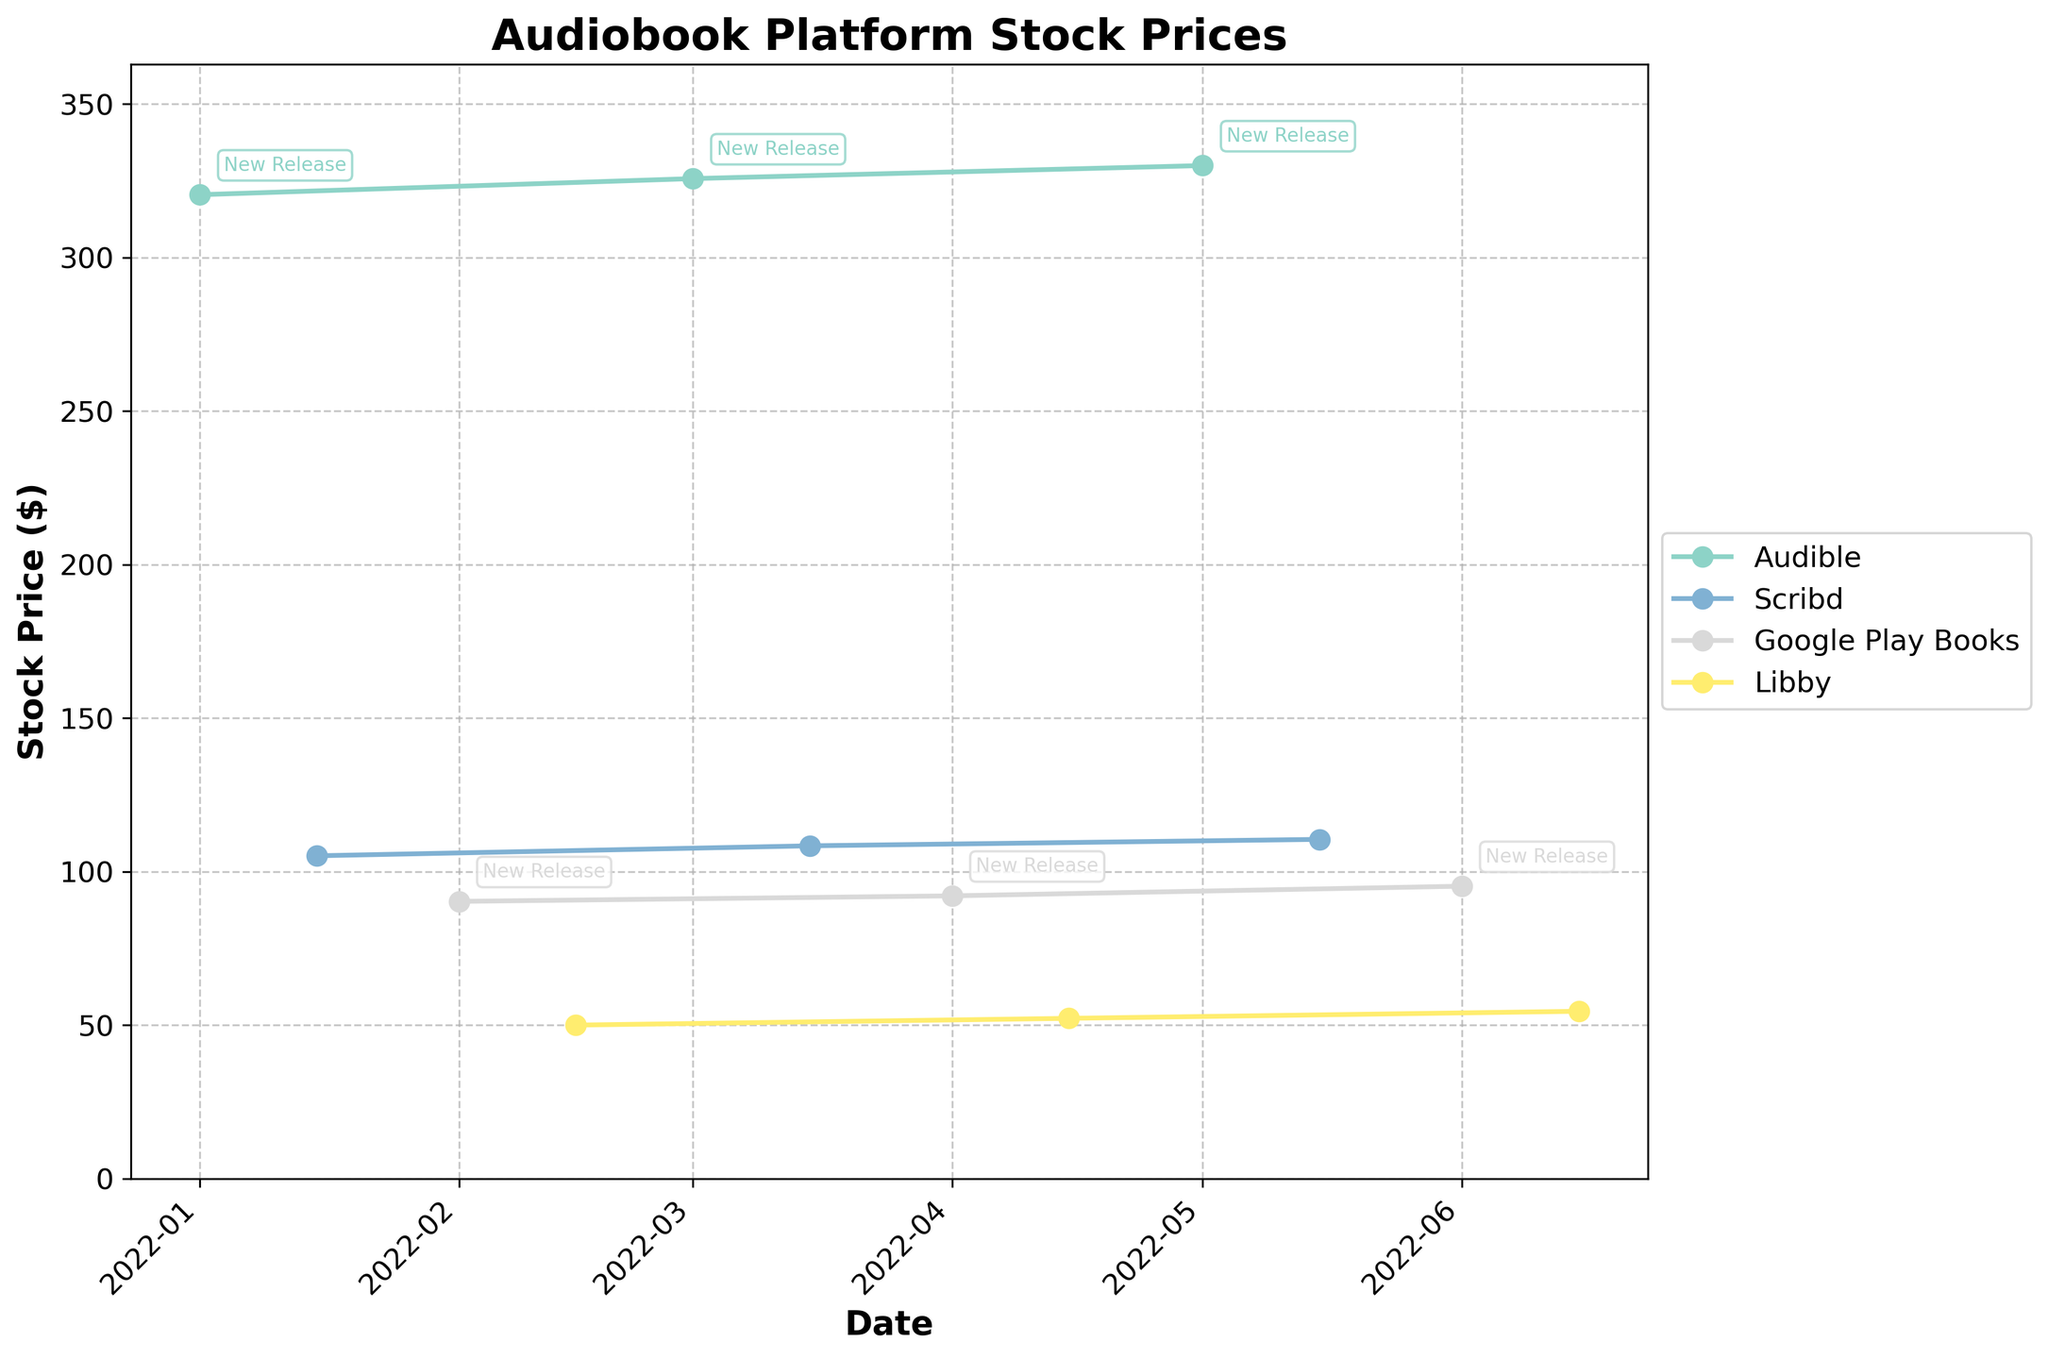What is the title of the plot? The title is typically located at the top of the plot and summarizes the content. In this plot, the title is displayed clearly there.
Answer: Audiobook Platform Stock Prices How many platforms are represented in the plot? The number of unique colors and labels in the legend indicates different platforms. Counting them gives the total number of platforms.
Answer: Four Which platform has the highest stock price throughout the period? By looking at the highest point(s) on the y-axis and finding the corresponding platform, we can see which one reached the highest stock price.
Answer: Audible When do new book releases occur? New book releases are marked with annotations saying "New Release." By checking the date next to these annotations, we can identify when they occur.
Answer: Every 1st of the month What is the stock price trend for Audible from Jan to Jun 2022? To find the trend, observe the points connected by the line for Audible and note the general direction (increasing, decreasing, or stable).
Answer: Increasing What is the difference in stock price for Google Play Books between February 1st and June 1st? Locate the two points on the plot for Google Play Books on those dates and subtract the February 1st stock price from the June 1st stock price.
Answer: 4.95 Which platform had the lowest stock price in June 2022? Checking the plot for the lowest y-axis value in June 2022, and noting the corresponding platform by its color and label.
Answer: Libby How does the stock price for Scribd on March 15th compare to its stock price on May 15th? Observe both the points for these dates for Scribd; compare their heights on the y-axis to find which is higher or if they are the same.
Answer: May 15th is higher Which date shows the highest stock price for Audible and what is its value? Locate the highest point on the y-axis for Audible, follow it to the x-axis to find the date, and read the corresponding stock price.
Answer: May 1st, 330.00 What is the general trend in stock price for Libby from January to June 2022? Check the points connected by the line for Libby from January to June; note the overall direction to identify the trend.
Answer: Increasing 